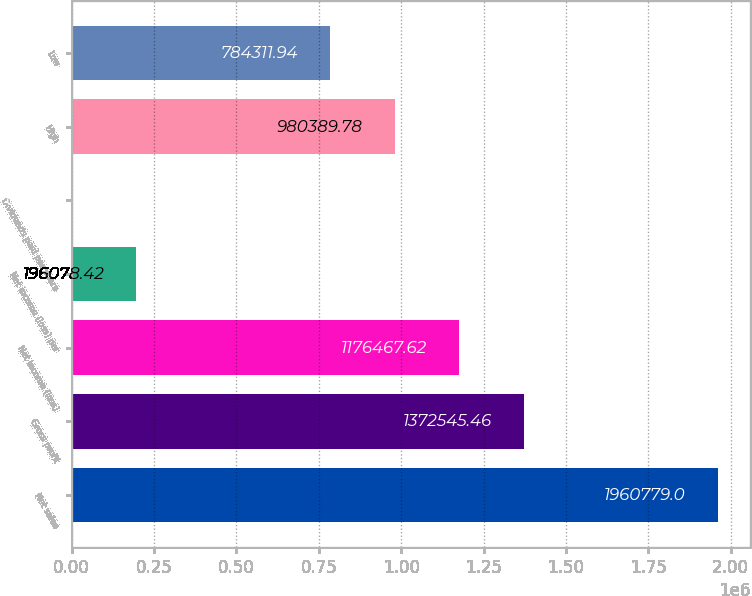<chart> <loc_0><loc_0><loc_500><loc_500><bar_chart><fcel>Net sales<fcel>Gross profit<fcel>Net income (loss)<fcel>Net income (loss) per<fcel>Dividends paid per share<fcel>High<fcel>Low<nl><fcel>1.96078e+06<fcel>1.37255e+06<fcel>1.17647e+06<fcel>196078<fcel>0.58<fcel>980390<fcel>784312<nl></chart> 